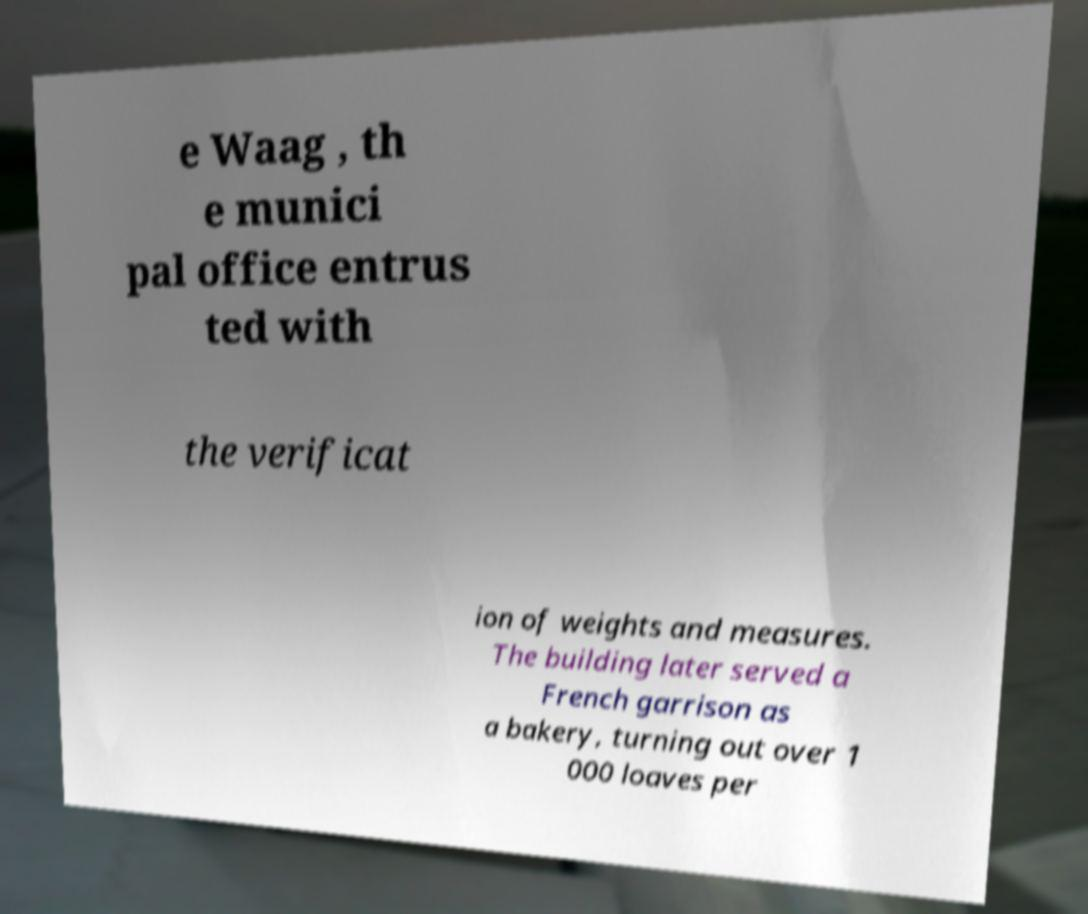Please identify and transcribe the text found in this image. e Waag , th e munici pal office entrus ted with the verificat ion of weights and measures. The building later served a French garrison as a bakery, turning out over 1 000 loaves per 